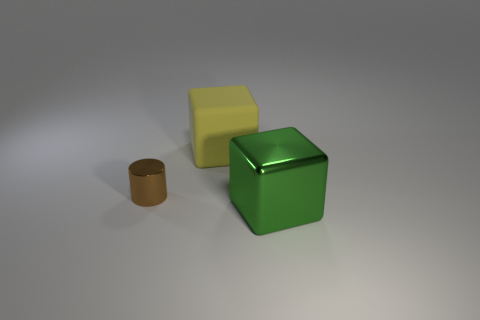Is there anything else that is made of the same material as the large yellow thing?
Provide a short and direct response. No. There is a large cube that is in front of the yellow matte thing; are there any metal blocks that are on the left side of it?
Give a very brief answer. No. Is the number of green metal objects right of the large green metallic thing less than the number of big matte things that are in front of the yellow object?
Offer a terse response. No. Are there any other things that are the same size as the rubber thing?
Your response must be concise. Yes. What is the shape of the large yellow rubber object?
Your answer should be compact. Cube. What material is the big thing that is to the left of the big green block?
Your answer should be compact. Rubber. There is a object that is on the right side of the cube that is behind the cube that is in front of the brown cylinder; what size is it?
Keep it short and to the point. Large. Are the large cube that is behind the green shiny cube and the large block that is to the right of the rubber cube made of the same material?
Give a very brief answer. No. How many things are either objects that are left of the large rubber thing or objects that are on the right side of the brown metal cylinder?
Your response must be concise. 3. What is the size of the metallic object behind the big object that is in front of the small object?
Keep it short and to the point. Small. 